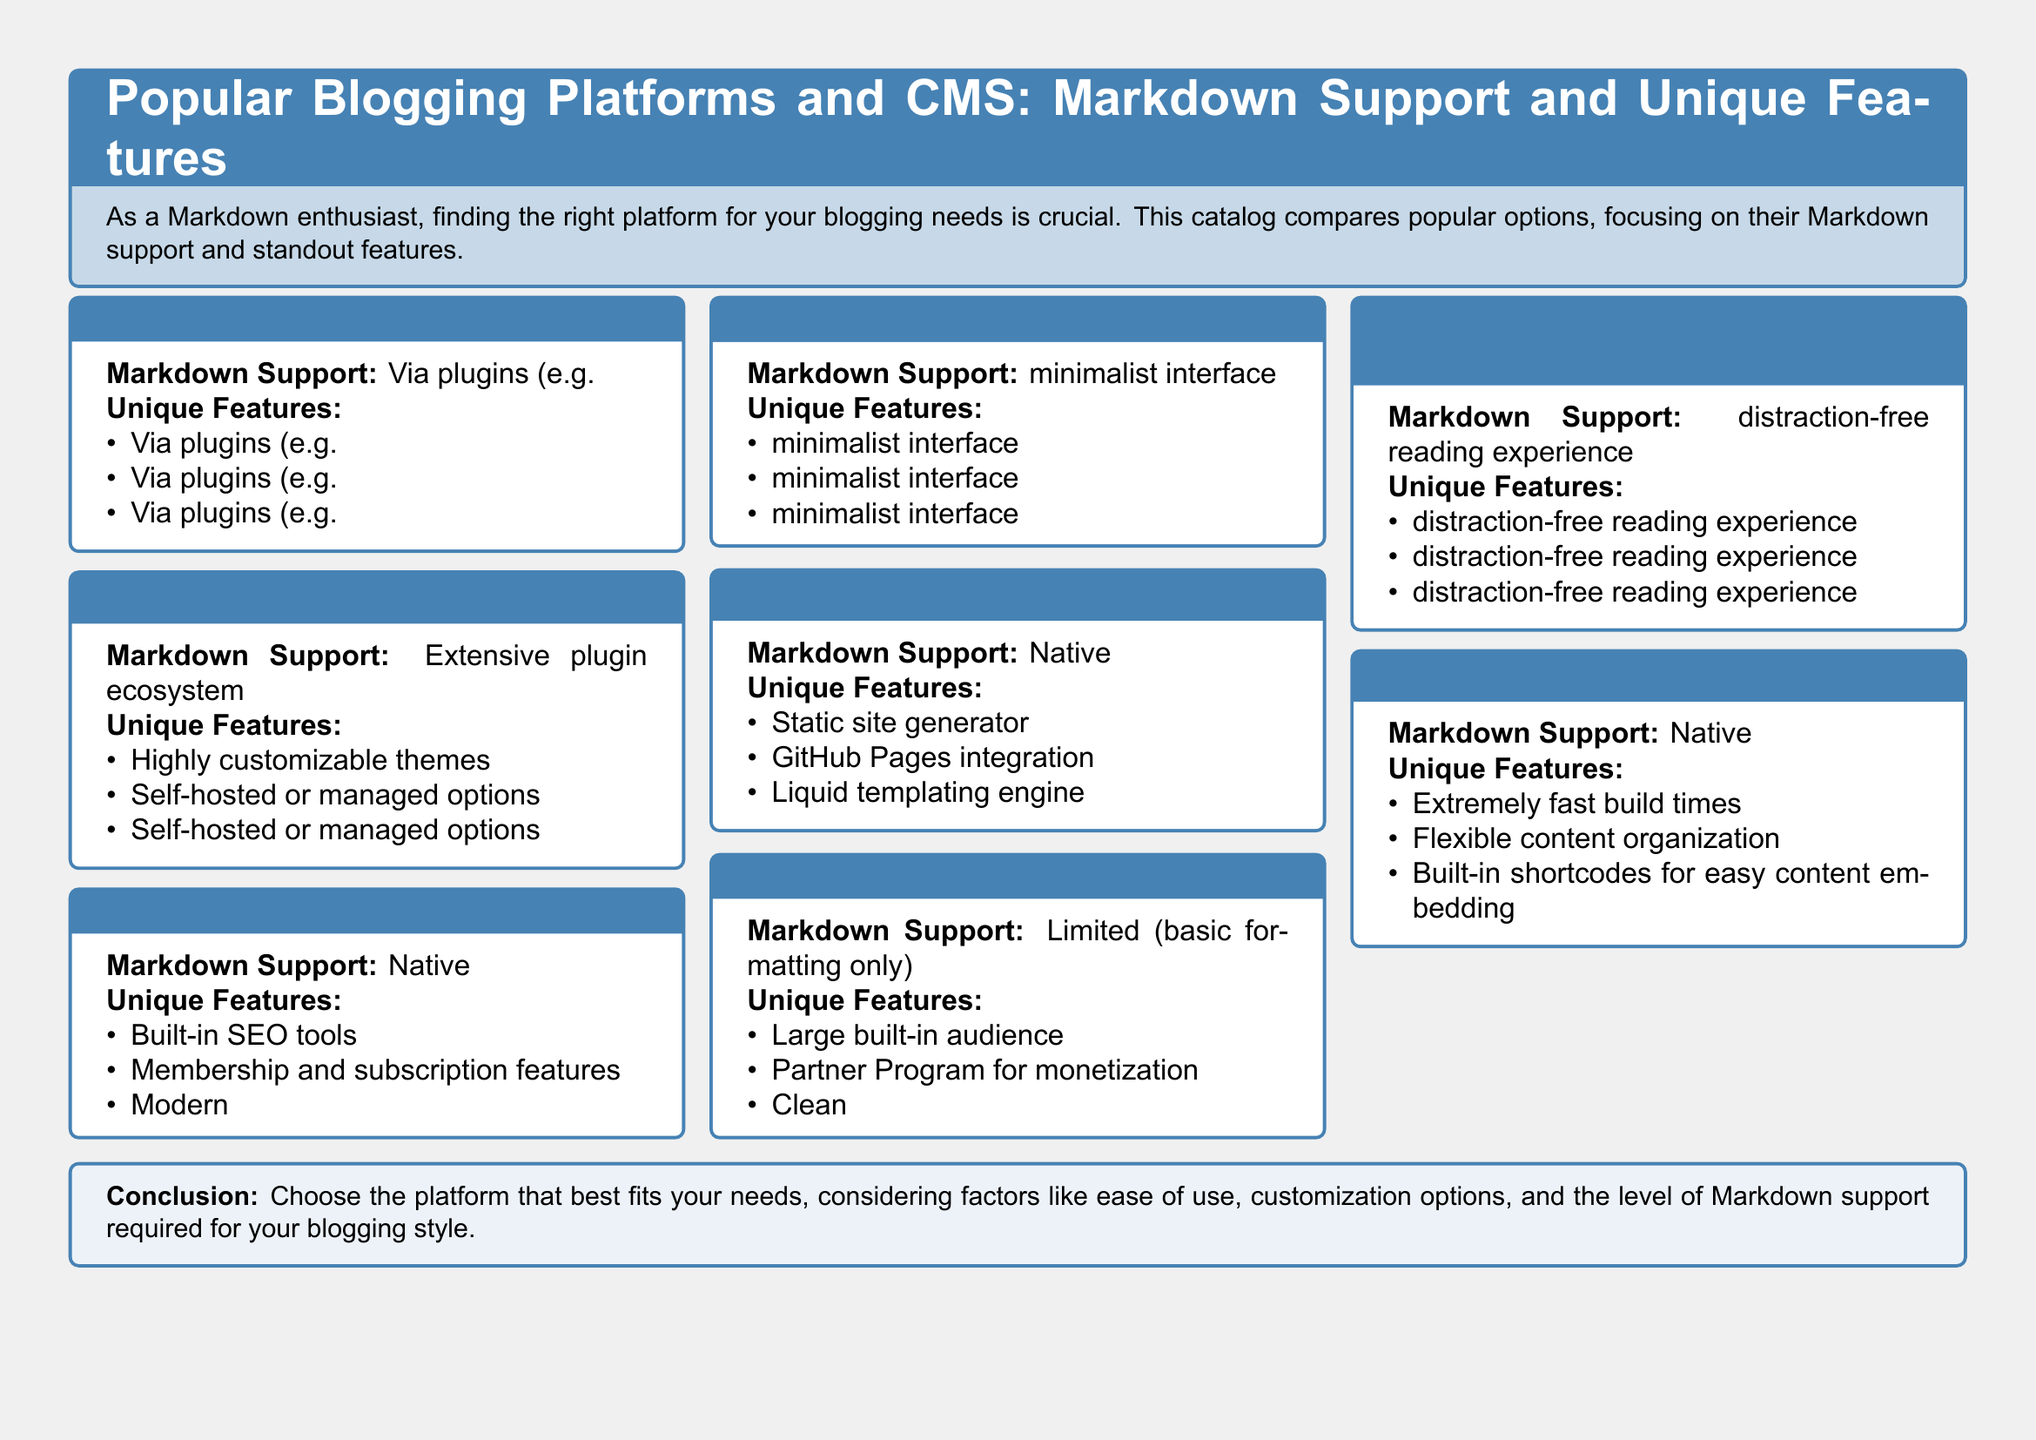What is the Markdown support of WordPress? WordPress uses plugins for Markdown support, specifically mentioning Jetpack.
Answer: Via plugins (e.g., Jetpack) What unique feature does Ghost offer? The document lists built-in SEO tools as one of Ghost's unique features.
Answer: Built-in SEO tools Which platform is described as a static site generator? Jekyll is explicitly categorized as a static site generator in the document.
Answer: Jekyll How many unique features are listed for each platform? The document details three unique features for every platform mentioned.
Answer: Three What is a distinguishing feature of Medium? The document highlights a large built-in audience as a unique feature of Medium.
Answer: Large built-in audience Which blogging platform has a minimalist interface? The document describes Ghost as having a modern, minimalist interface.
Answer: Ghost What is the Markdown support of Hugo? Hugo's Markdown support is categorized as native according to the document.
Answer: Native What type of interface does Medium offer? The document describes Medium's reading experience as clean and distraction-free.
Answer: Clean, distraction-free reading experience What platform integrates with GitHub Pages? Jekyll is noted for its integration with GitHub Pages in the document.
Answer: Jekyll 